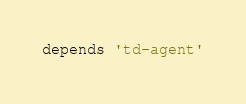<code> <loc_0><loc_0><loc_500><loc_500><_Ruby_>
depends 'td-agent'
</code> 